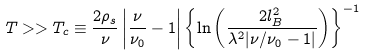Convert formula to latex. <formula><loc_0><loc_0><loc_500><loc_500>T > > T _ { c } \equiv \frac { 2 \rho _ { s } } { \nu } \left | \frac { \nu } { \nu _ { 0 } } - 1 \right | \left \{ \ln \left ( \frac { 2 l _ { B } ^ { 2 } } { \lambda ^ { 2 } | \nu / \nu _ { 0 } - 1 | } \right ) \right \} ^ { - 1 }</formula> 